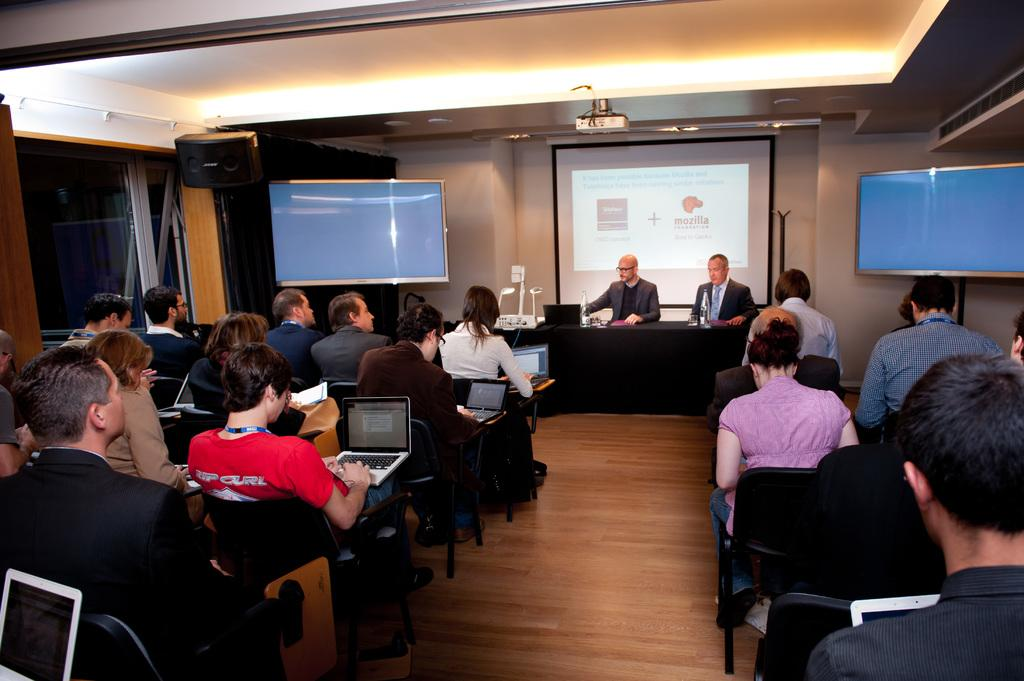How many people are wearing suits in the image? There are two persons wearing suits in the image. What are the two persons doing in the image? The two persons are sitting in front of a table. What can be seen behind the two persons? There is a projected image behind the two persons. Who is present in front of the two persons? There is a group of people sitting in front of the two persons. What type of bushes can be seen in the image? There are no bushes present in the image. What is the profession of the carpenter in the image? There is no carpenter present in the image. 